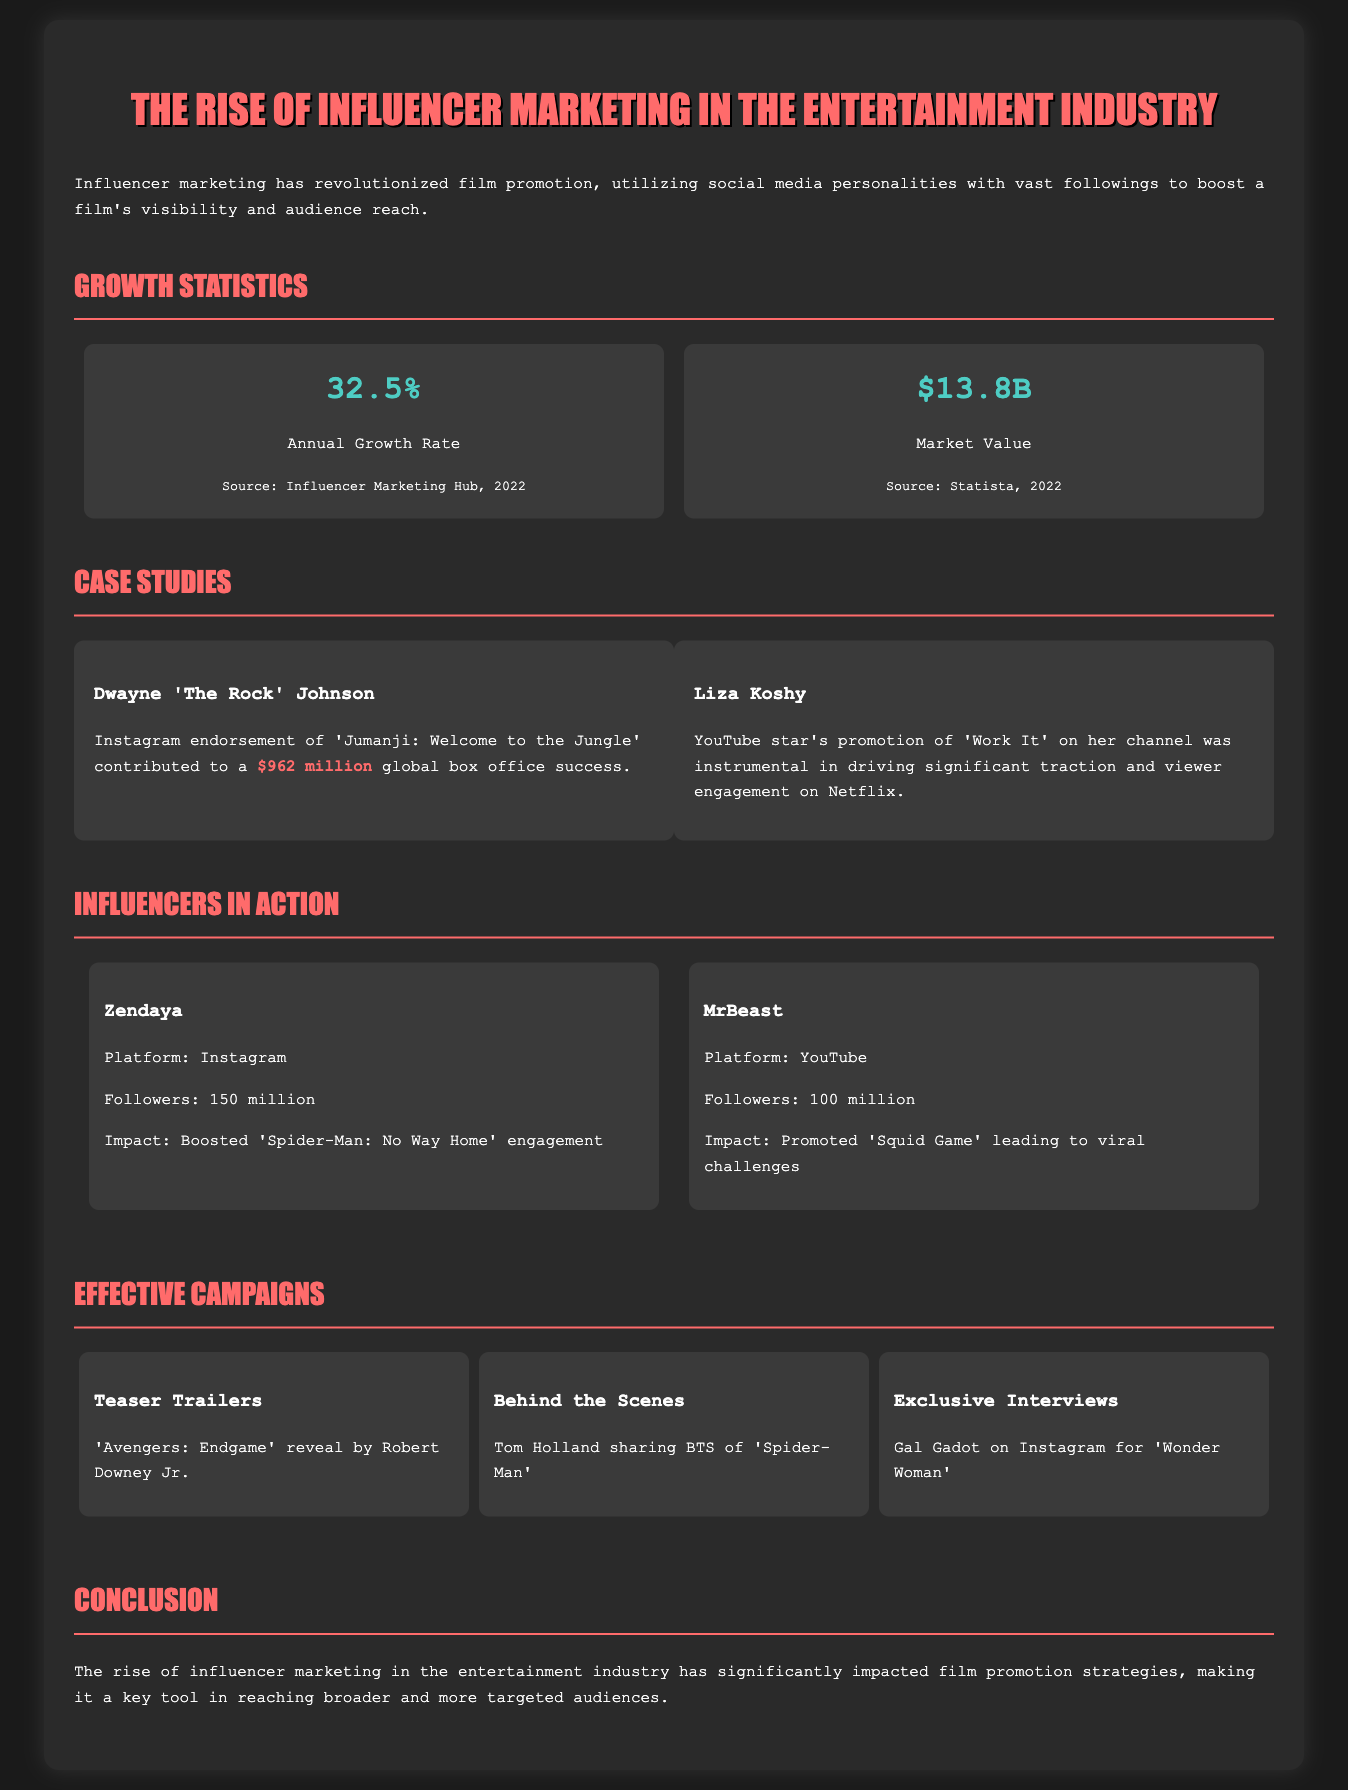What is the annual growth rate of influencer marketing? The annual growth rate of influencer marketing is stated as 32.5%.
Answer: 32.5% What is the market value of influencer marketing? The market value of influencer marketing is noted as $13.8 billion.
Answer: $13.8B Which influencer promoted 'Jumanji: Welcome to the Jungle'? Dwayne 'The Rock' Johnson is mentioned as the influencer who endorsed 'Jumanji: Welcome to the Jungle'.
Answer: Dwayne 'The Rock' Johnson What was the significant impact of Liza Koshy's promotion? Liza Koshy's promotion was instrumental in driving significant traction and viewer engagement on Netflix for 'Work It'.
Answer: Viewer engagement How many followers does Zendaya have on Instagram? Zendaya is noted to have 150 million followers on Instagram.
Answer: 150 million What campaign element involved Robert Downey Jr.? Robert Downey Jr. was involved in the campaign element of teaser trailers for 'Avengers: Endgame'.
Answer: Teaser Trailers Which film experienced a viral promotion due to MrBeast? The film 'Squid Game' experienced a viral promotion due to MrBeast.
Answer: Squid Game What type of content did Tom Holland share? Tom Holland shared behind-the-scenes content for 'Spider-Man'.
Answer: Behind the Scenes What is highlighted as key in reaching broader audiences? The rise of influencer marketing is highlighted as key in reaching broader and more targeted audiences.
Answer: Influencer marketing 